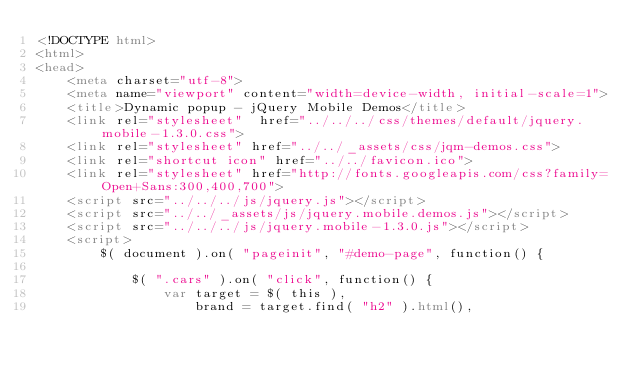<code> <loc_0><loc_0><loc_500><loc_500><_HTML_><!DOCTYPE html>
<html>
<head>
	<meta charset="utf-8">
	<meta name="viewport" content="width=device-width, initial-scale=1">
	<title>Dynamic popup - jQuery Mobile Demos</title>
	<link rel="stylesheet"  href="../../../css/themes/default/jquery.mobile-1.3.0.css">
	<link rel="stylesheet" href="../../_assets/css/jqm-demos.css">
	<link rel="shortcut icon" href="../../favicon.ico">
	<link rel="stylesheet" href="http://fonts.googleapis.com/css?family=Open+Sans:300,400,700">
	<script src="../../../js/jquery.js"></script>
	<script src="../../_assets/js/jquery.mobile.demos.js"></script>
	<script src="../../../js/jquery.mobile-1.3.0.js"></script>
	<script>
		$( document ).on( "pageinit", "#demo-page", function() {

			$( ".cars" ).on( "click", function() {
				var target = $( this ),
					brand = target.find( "h2" ).html(),</code> 